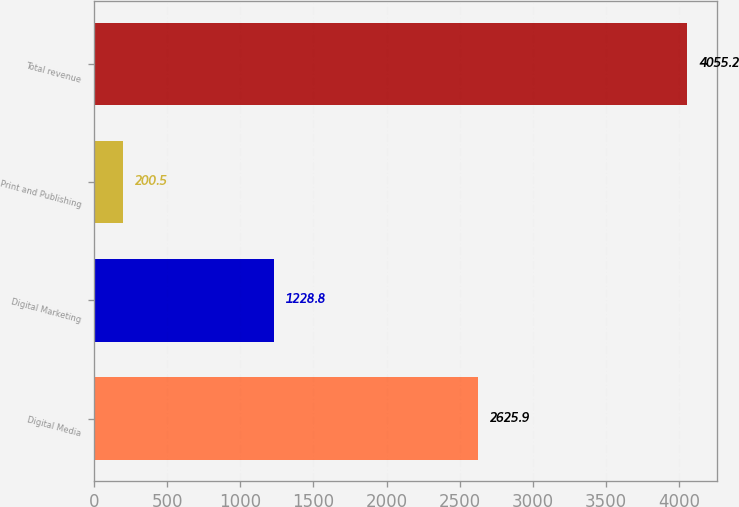Convert chart. <chart><loc_0><loc_0><loc_500><loc_500><bar_chart><fcel>Digital Media<fcel>Digital Marketing<fcel>Print and Publishing<fcel>Total revenue<nl><fcel>2625.9<fcel>1228.8<fcel>200.5<fcel>4055.2<nl></chart> 